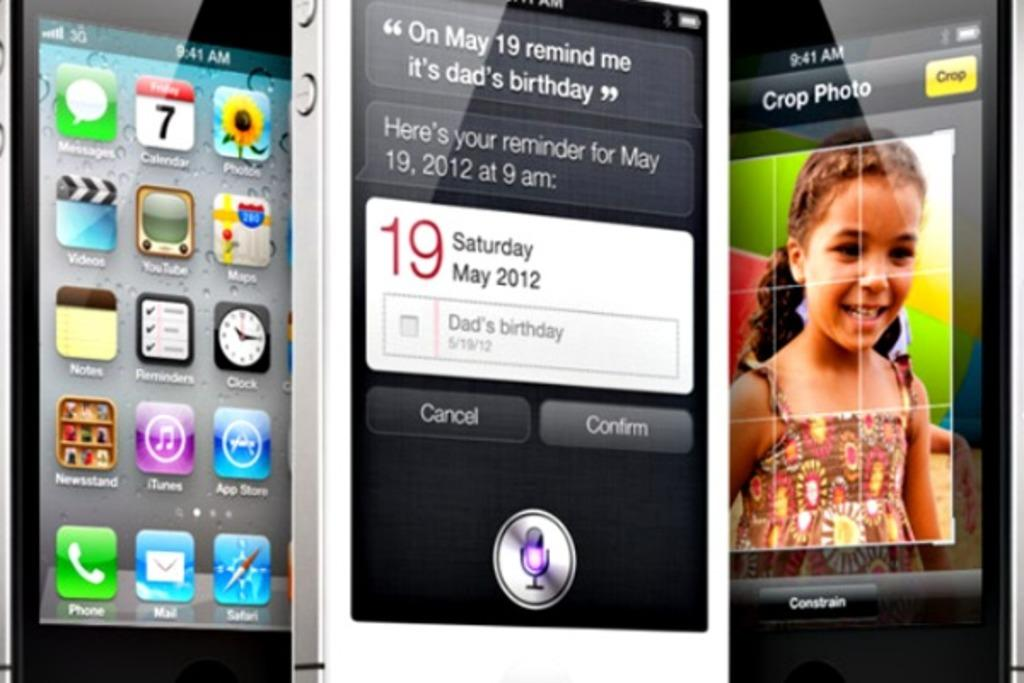<image>
Provide a brief description of the given image. a phone with the number 19 on it 